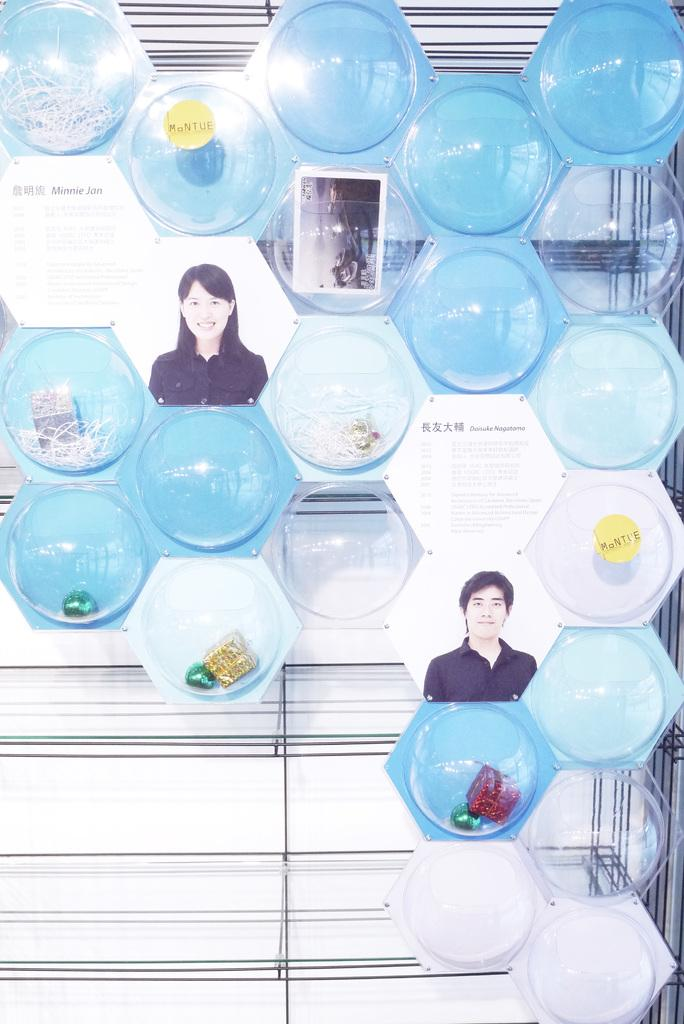What is the main subject in the center of the image? There is a collage frame in the center of the image. Who is the creator of the breath visible in the image? There is no breath visible in the image, and therefore no creator can be identified. 